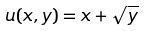<formula> <loc_0><loc_0><loc_500><loc_500>u ( x , y ) = x + \sqrt { y }</formula> 